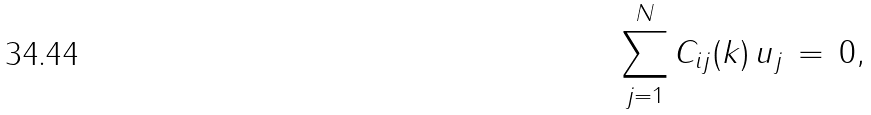<formula> <loc_0><loc_0><loc_500><loc_500>\sum _ { j = 1 } ^ { N } C _ { i j } ( k ) \, u _ { j } \, = \, 0 ,</formula> 